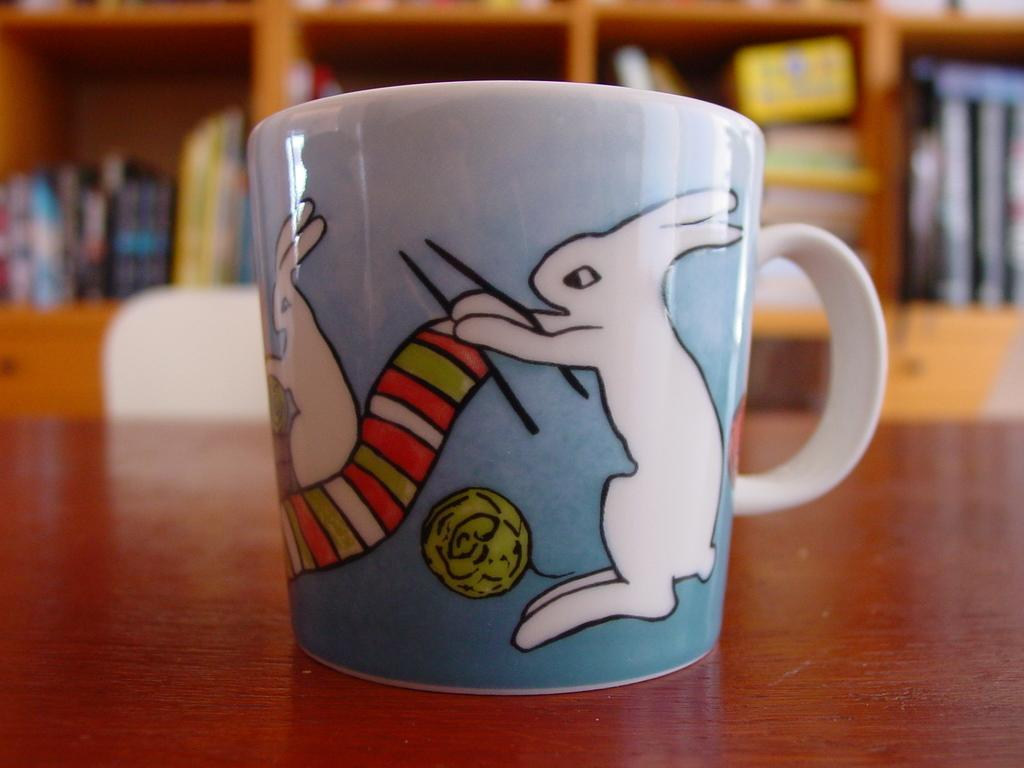What is located in the foreground of the image? There is a cup in the foreground of the image. What is the cup placed on? The cup is on a wooden surface. What can be seen in the background of the image? There is a chair and objects on a shelf in the background of the image. What type of objects are on the shelf? There are books on the shelf in the background of the image. How many muscles can be seen flexing in the image? There are no muscles visible in the image. What type of minister is present in the image? There is no minister present in the image. 